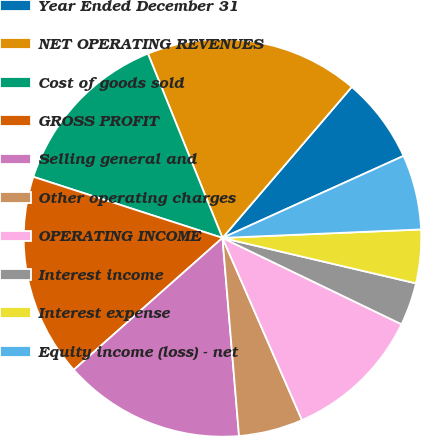Convert chart. <chart><loc_0><loc_0><loc_500><loc_500><pie_chart><fcel>Year Ended December 31<fcel>NET OPERATING REVENUES<fcel>Cost of goods sold<fcel>GROSS PROFIT<fcel>Selling general and<fcel>Other operating charges<fcel>OPERATING INCOME<fcel>Interest income<fcel>Interest expense<fcel>Equity income (loss) - net<nl><fcel>6.96%<fcel>17.39%<fcel>13.91%<fcel>16.52%<fcel>14.78%<fcel>5.22%<fcel>11.3%<fcel>3.48%<fcel>4.35%<fcel>6.09%<nl></chart> 